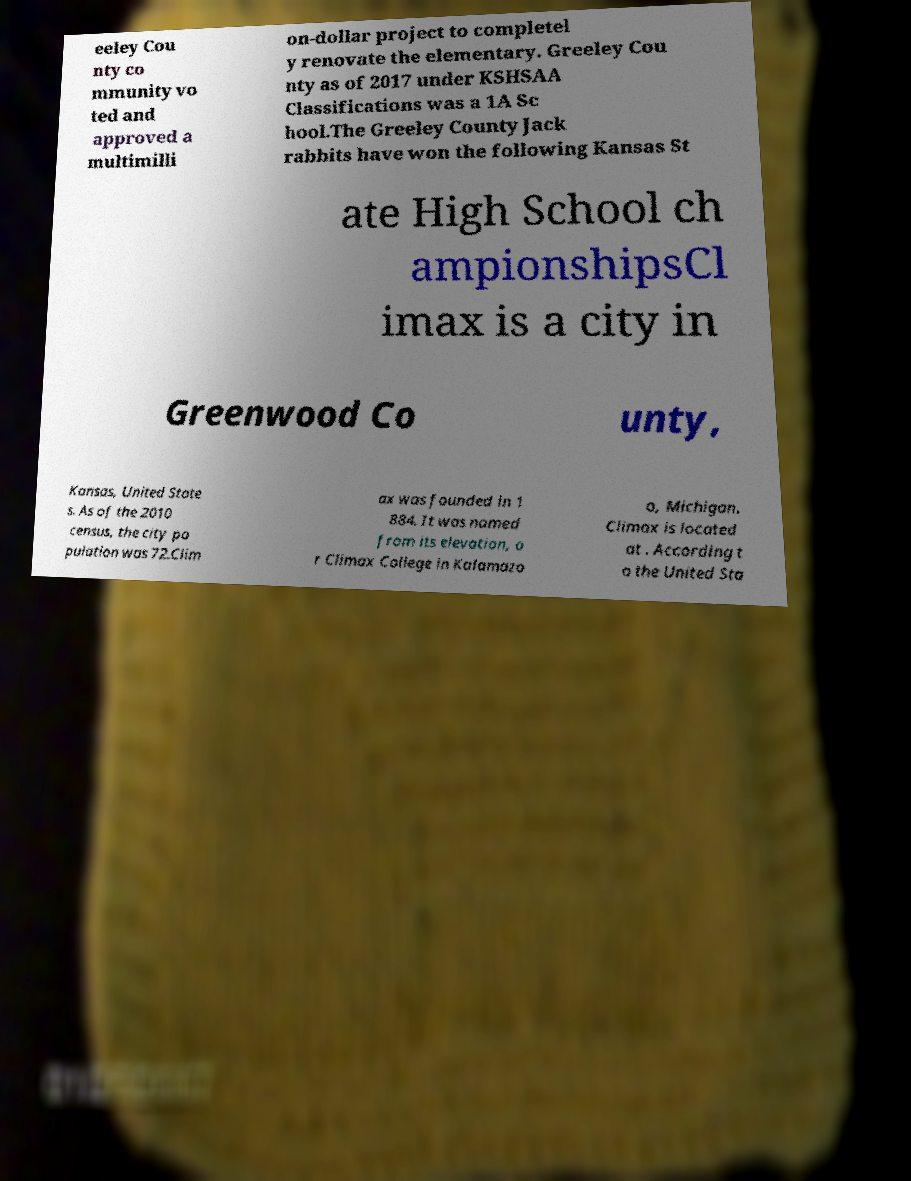Can you read and provide the text displayed in the image?This photo seems to have some interesting text. Can you extract and type it out for me? eeley Cou nty co mmunity vo ted and approved a multimilli on-dollar project to completel y renovate the elementary. Greeley Cou nty as of 2017 under KSHSAA Classifications was a 1A Sc hool.The Greeley County Jack rabbits have won the following Kansas St ate High School ch ampionshipsCl imax is a city in Greenwood Co unty, Kansas, United State s. As of the 2010 census, the city po pulation was 72.Clim ax was founded in 1 884. It was named from its elevation, o r Climax College in Kalamazo o, Michigan. Climax is located at . According t o the United Sta 